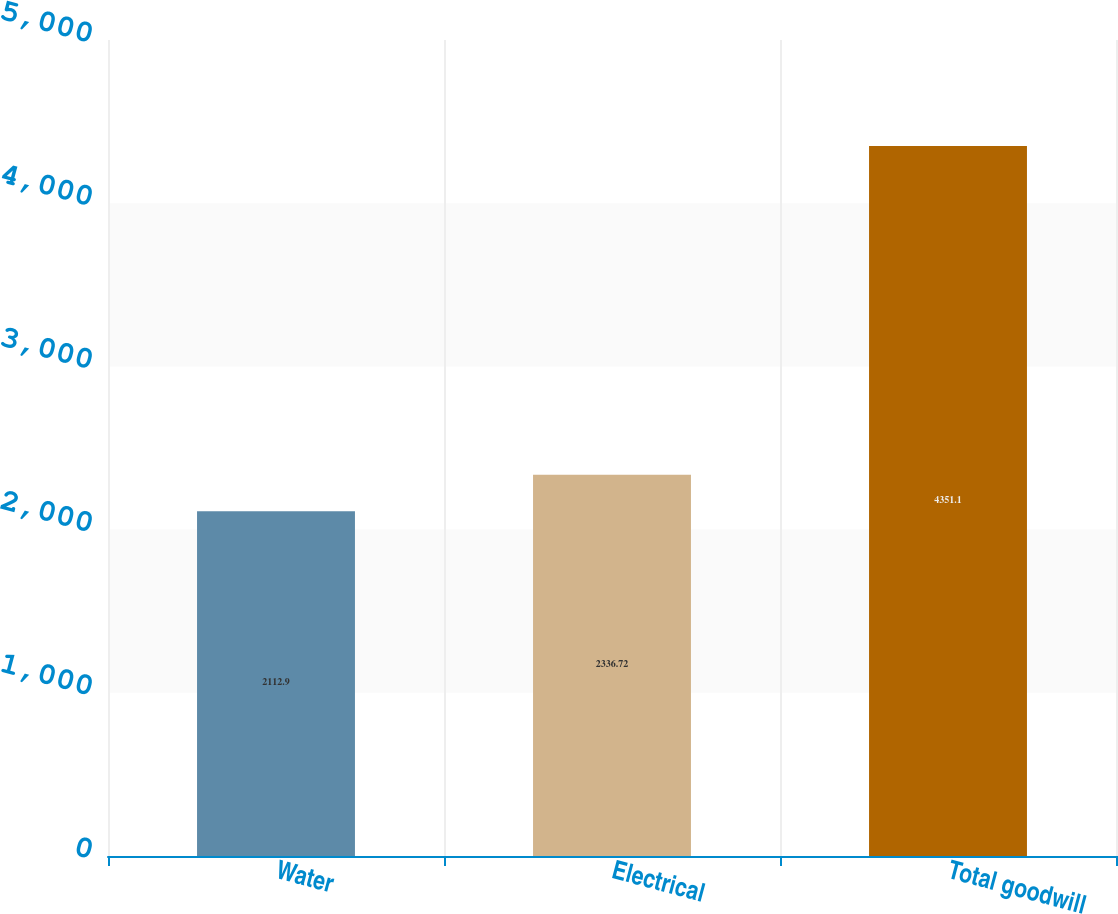<chart> <loc_0><loc_0><loc_500><loc_500><bar_chart><fcel>Water<fcel>Electrical<fcel>Total goodwill<nl><fcel>2112.9<fcel>2336.72<fcel>4351.1<nl></chart> 